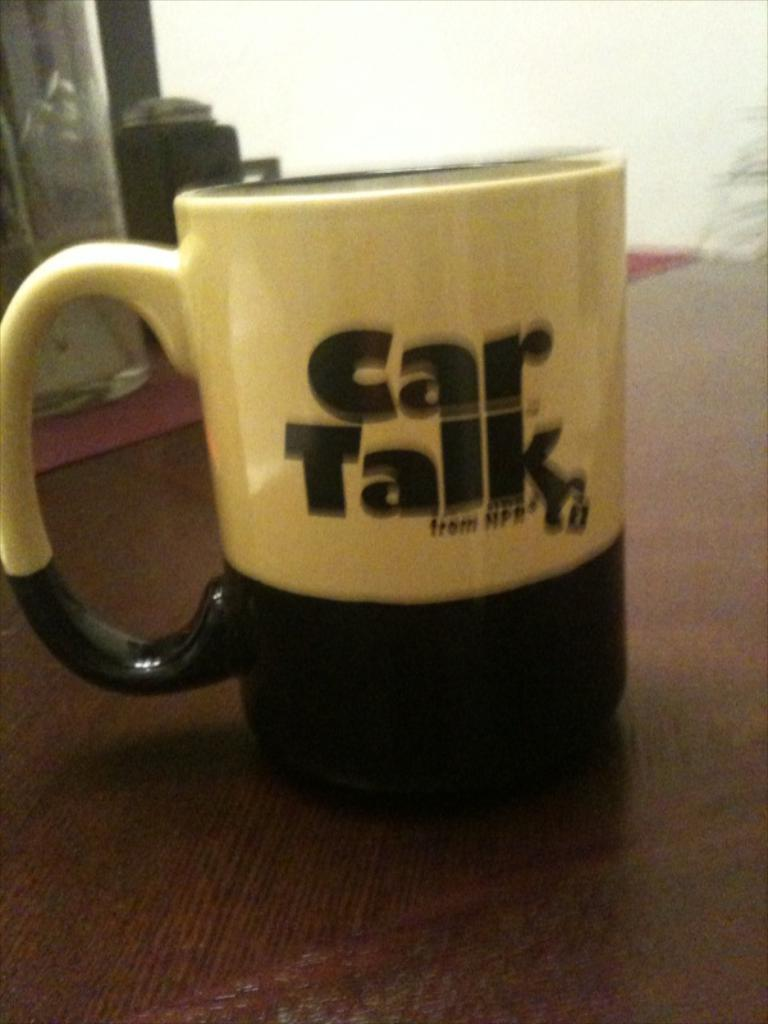Provide a one-sentence caption for the provided image. A coffee mug advertises an NPR show about cars. 